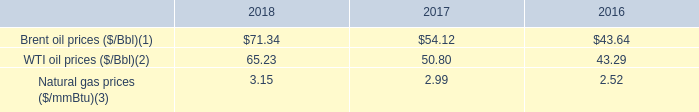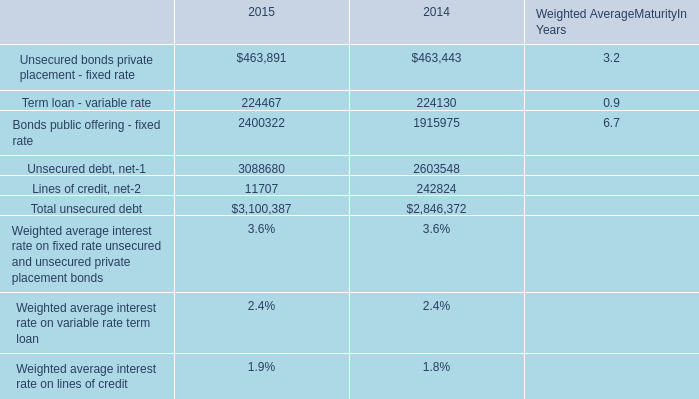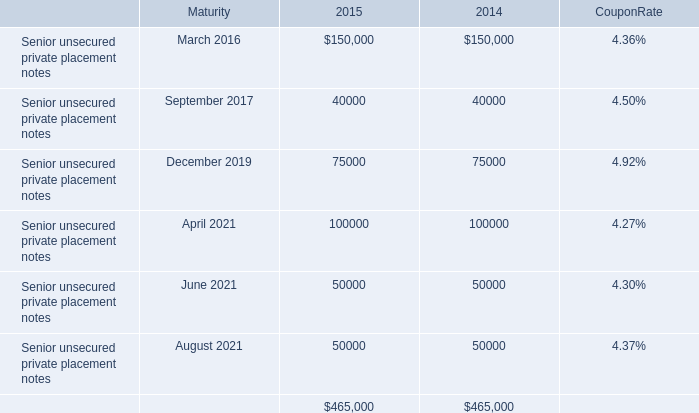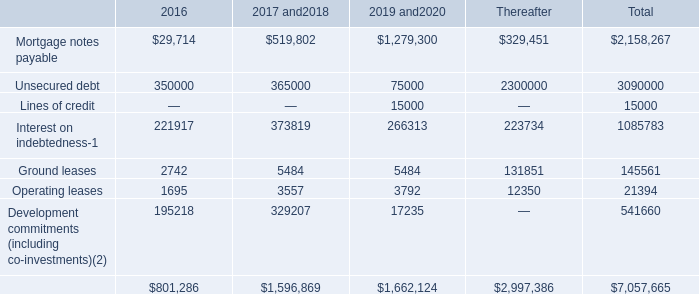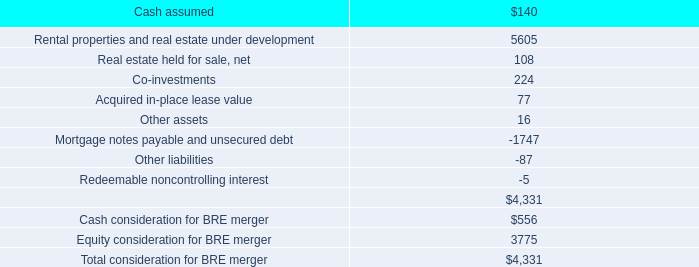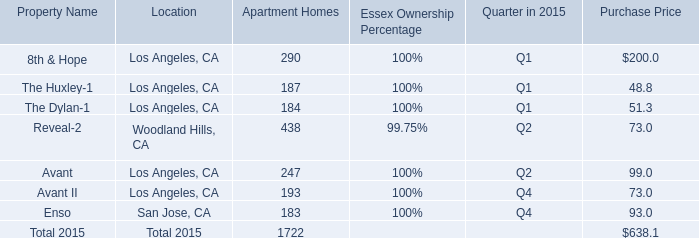What is the ratio of all Apartment Homes that are smaller than 400 to the sum of Apartment Homes in 2015? 
Computations: ((((((290 + 187) + 184) + 247) + 193) + 183) / ((((((290 + 187) + 184) + 438) + 247) + 193) + 183))
Answer: 0.74564. 